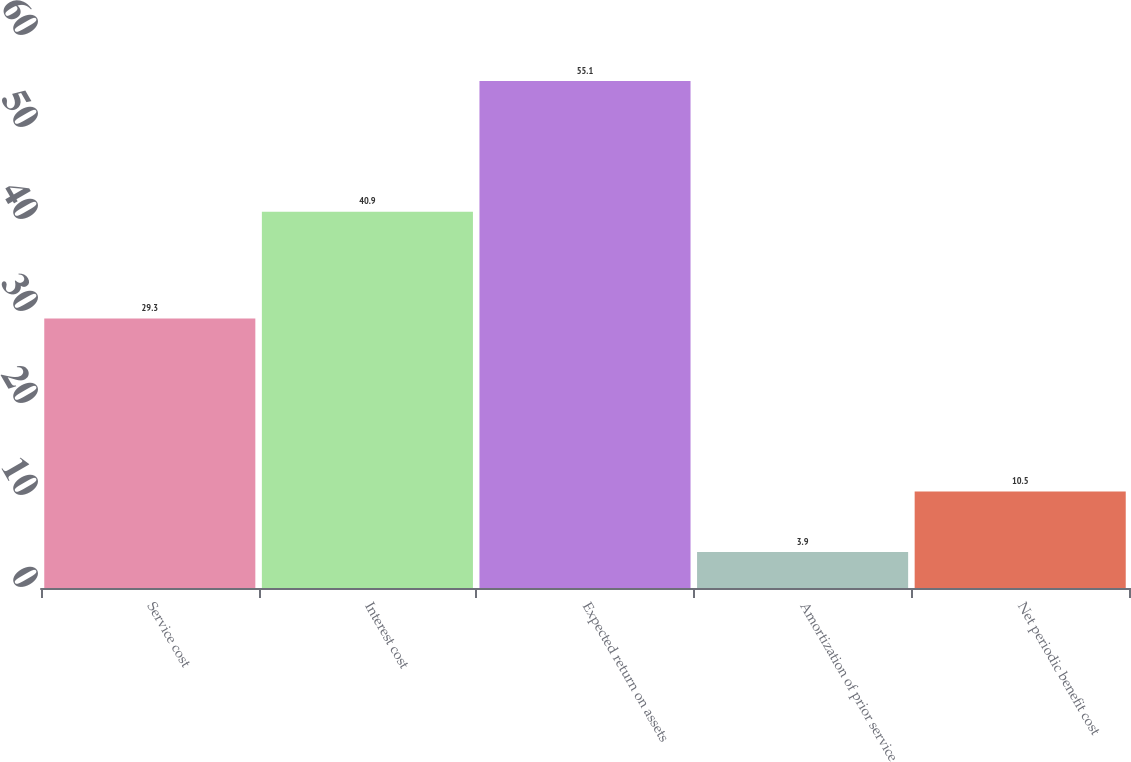<chart> <loc_0><loc_0><loc_500><loc_500><bar_chart><fcel>Service cost<fcel>Interest cost<fcel>Expected return on assets<fcel>Amortization of prior service<fcel>Net periodic benefit cost<nl><fcel>29.3<fcel>40.9<fcel>55.1<fcel>3.9<fcel>10.5<nl></chart> 